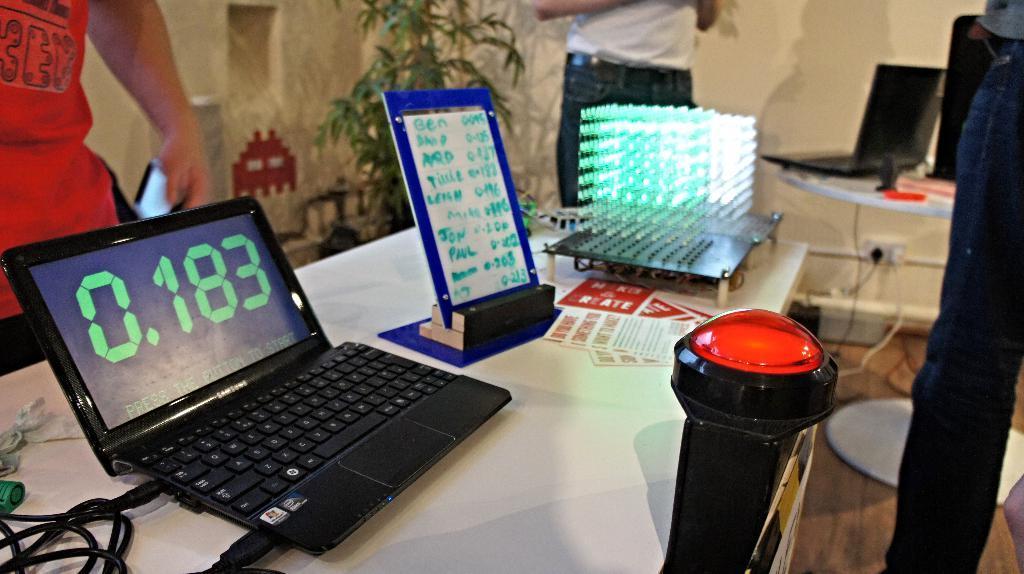In one or two sentences, can you explain what this image depicts? On this table there are papers, laptop, cables, board and device. Persons are standing. Far there is a plant. On this table there is a laptop. 